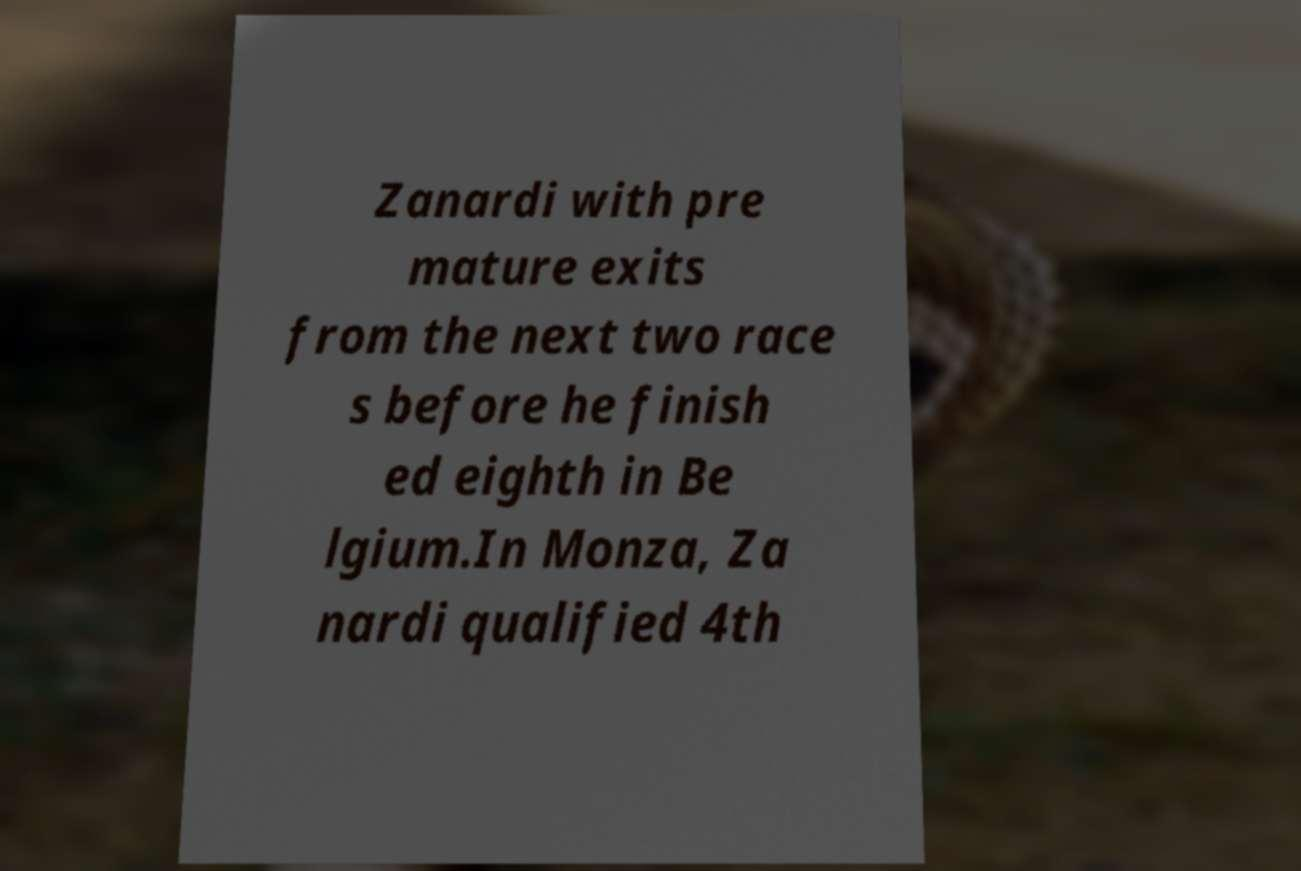There's text embedded in this image that I need extracted. Can you transcribe it verbatim? Zanardi with pre mature exits from the next two race s before he finish ed eighth in Be lgium.In Monza, Za nardi qualified 4th 